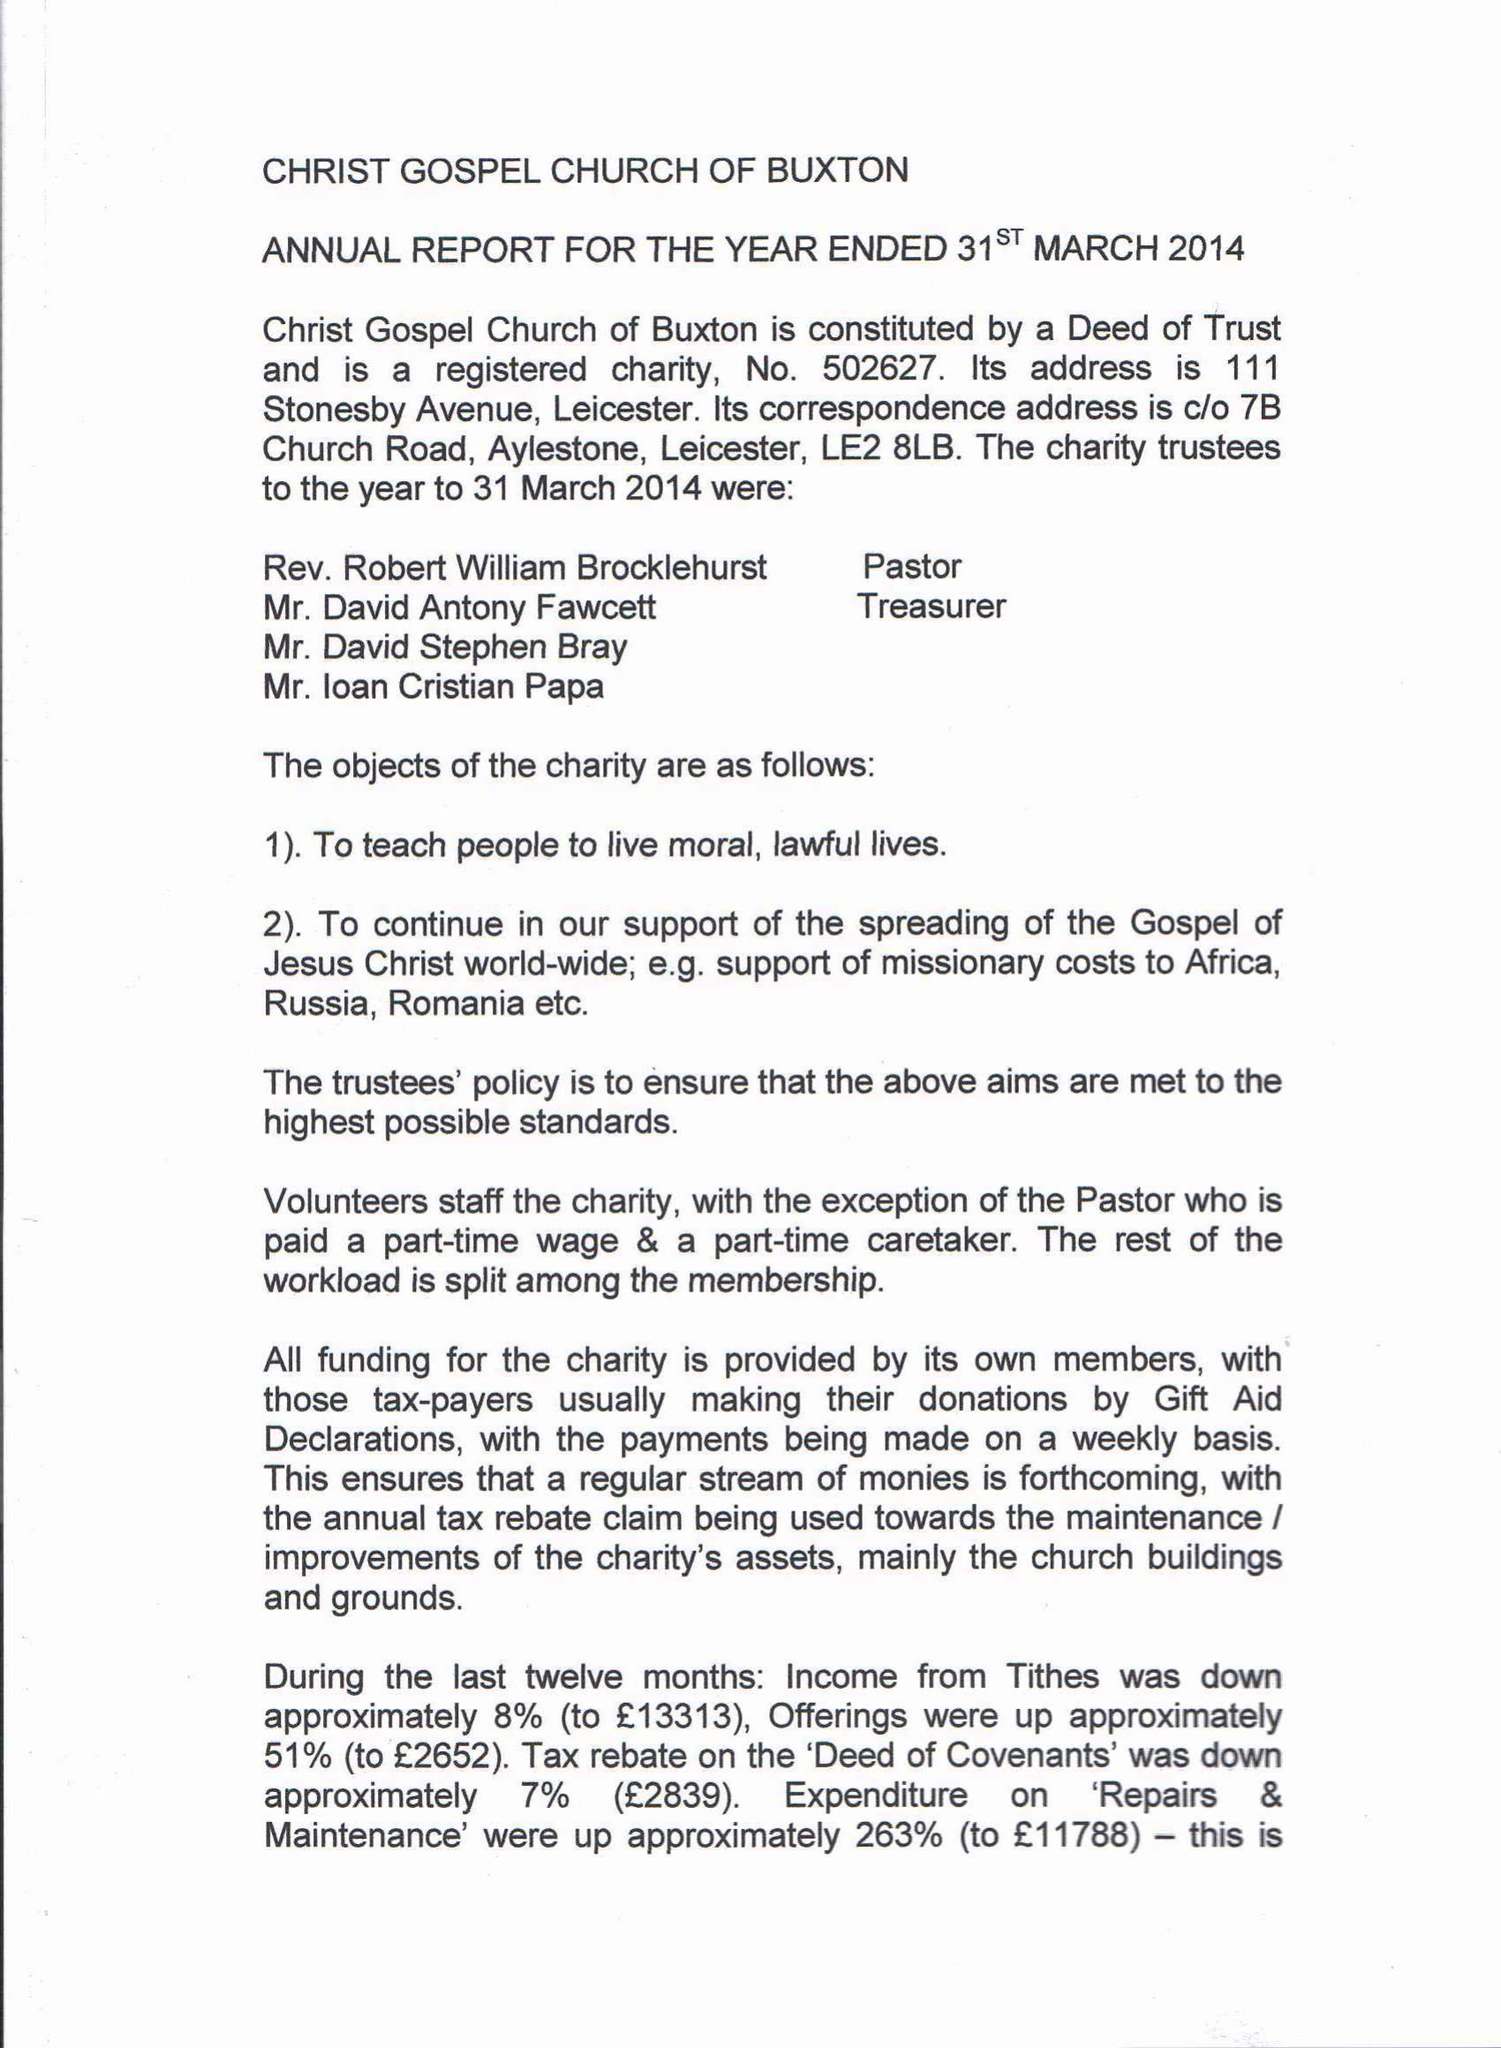What is the value for the address__postcode?
Answer the question using a single word or phrase. LE2 8LB 